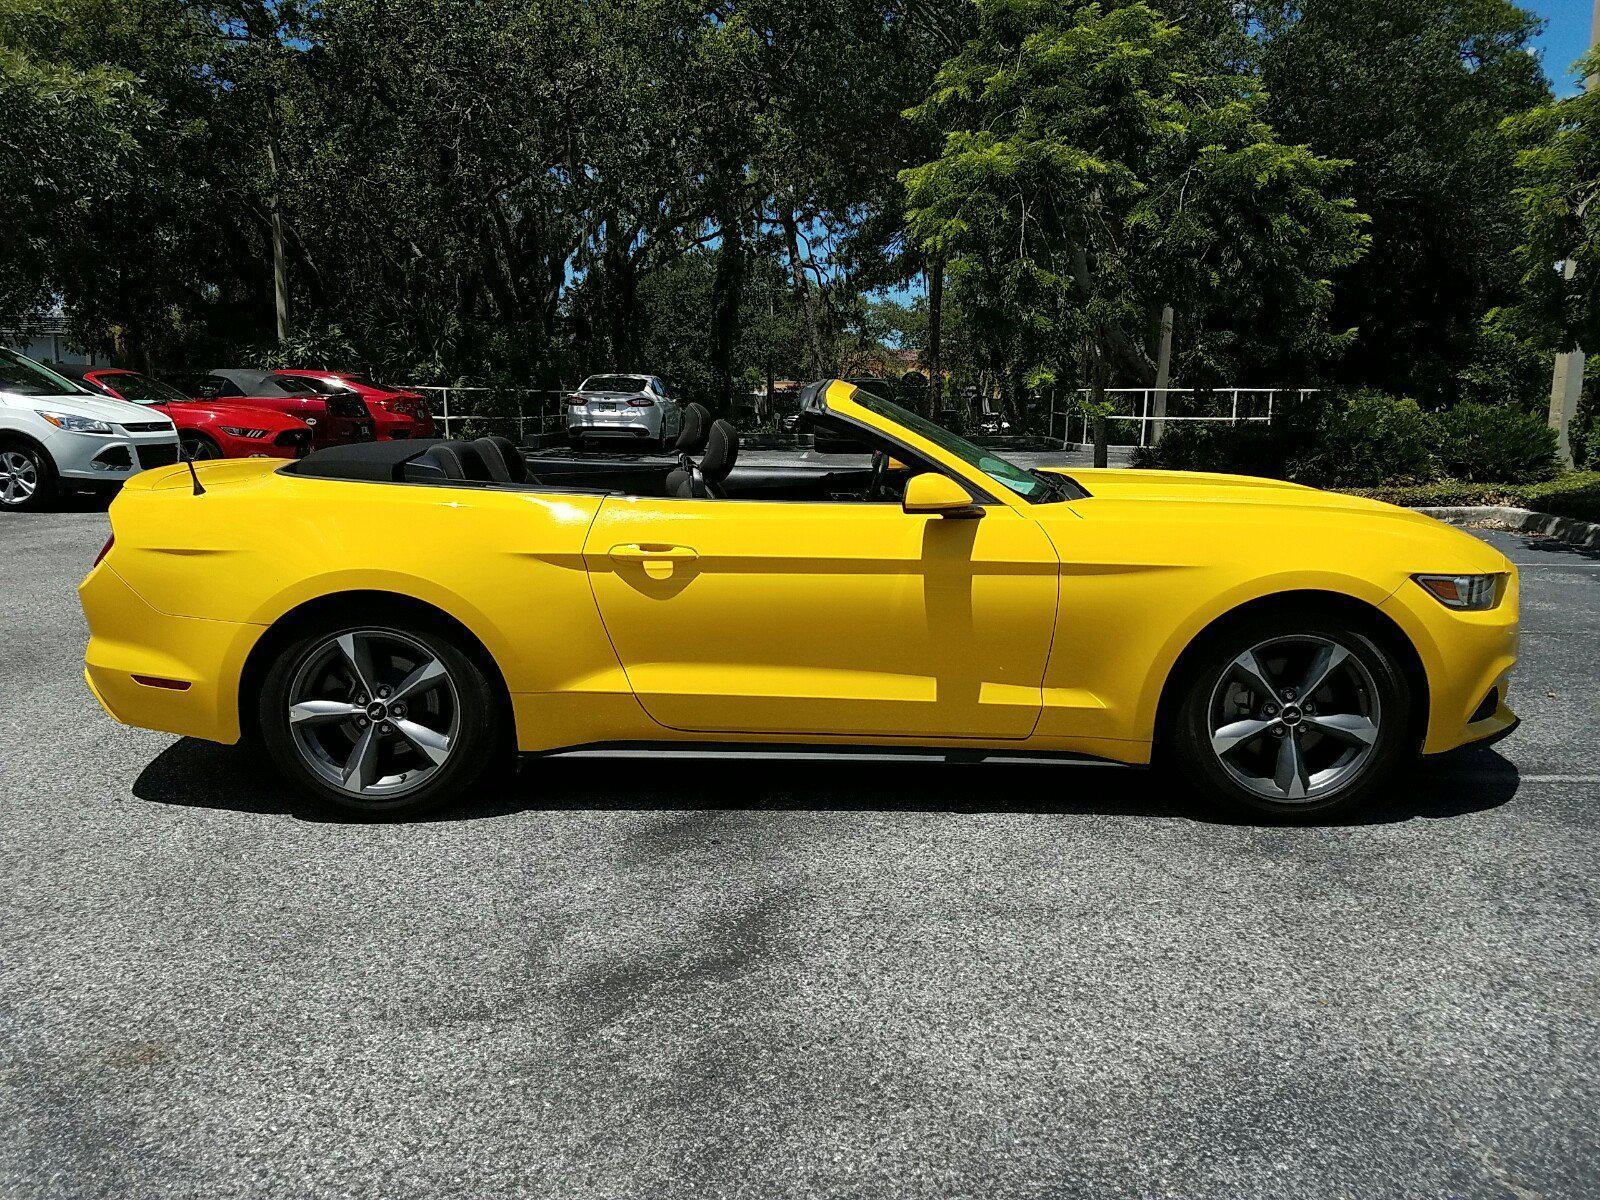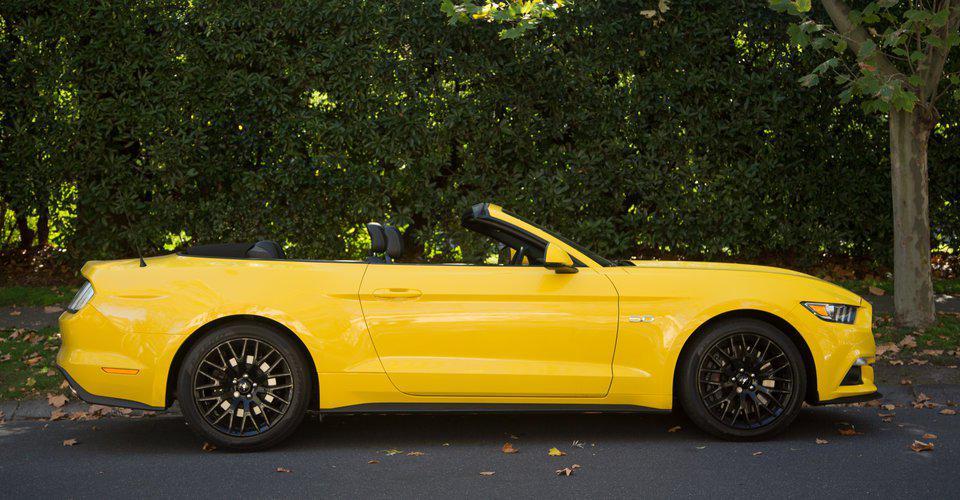The first image is the image on the left, the second image is the image on the right. Examine the images to the left and right. Is the description "One image shows a leftward-angled yellow convertible without a hood stripe, and the other features a right-turned convertible with black stripes on its hood." accurate? Answer yes or no. No. The first image is the image on the left, the second image is the image on the right. Assess this claim about the two images: "The right image contains one yellow car that is facing towards the right.". Correct or not? Answer yes or no. Yes. 